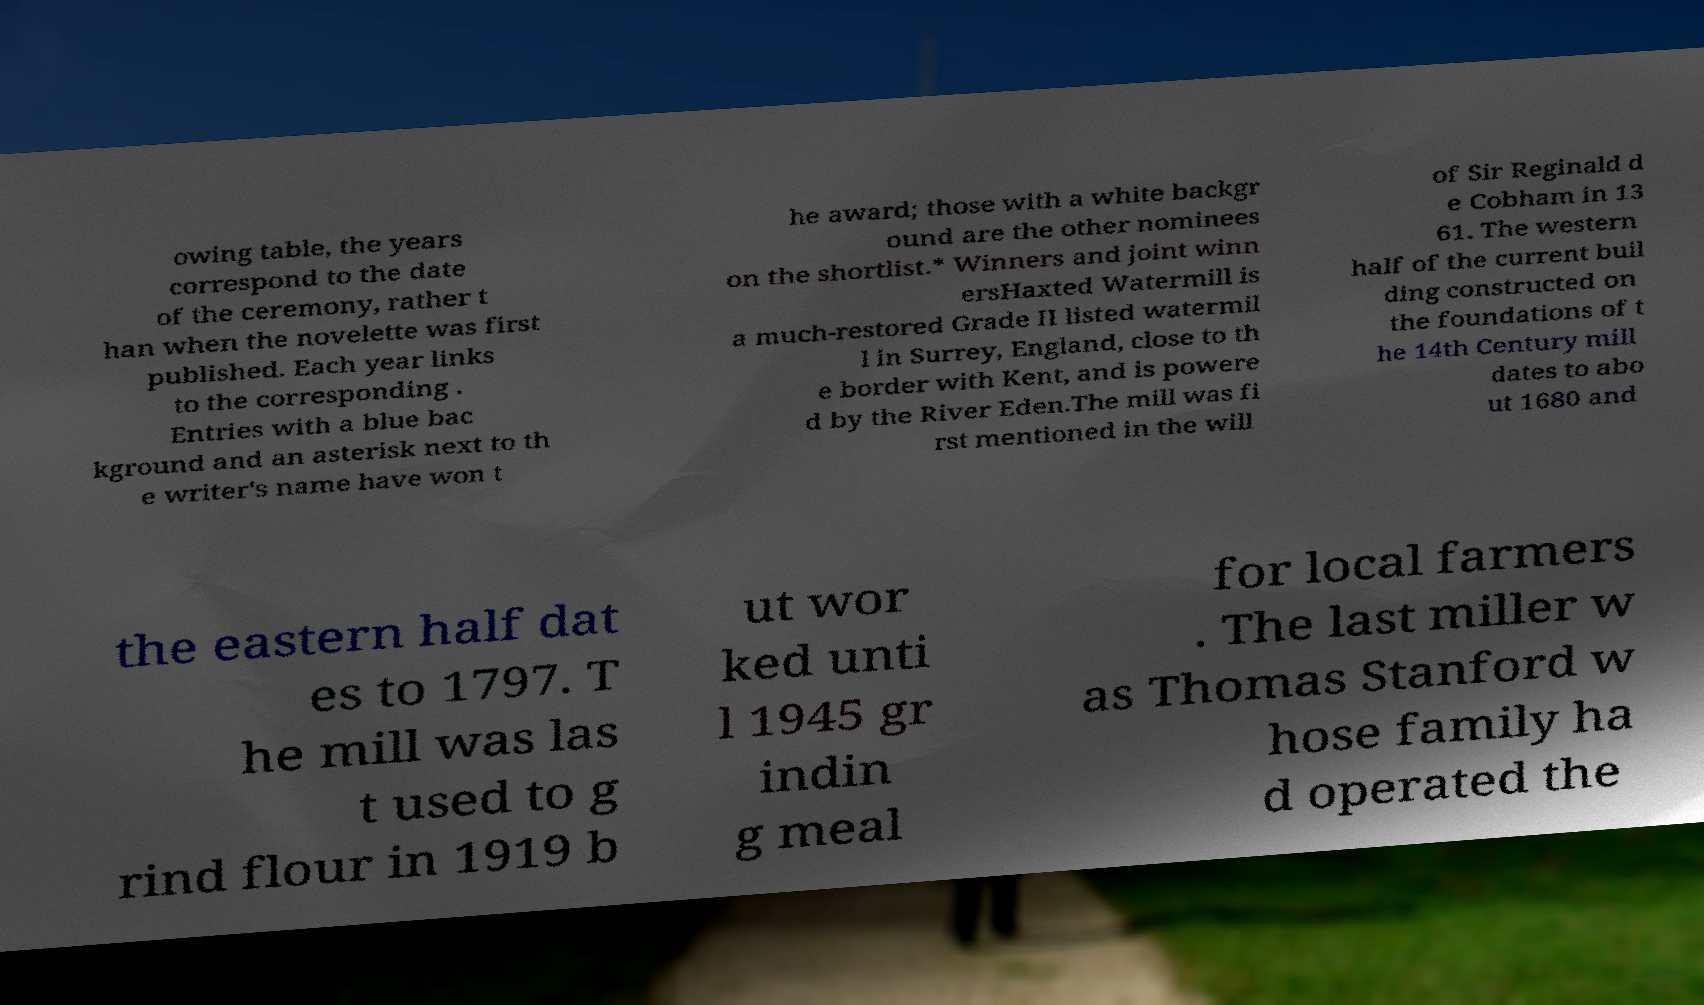Could you assist in decoding the text presented in this image and type it out clearly? owing table, the years correspond to the date of the ceremony, rather t han when the novelette was first published. Each year links to the corresponding . Entries with a blue bac kground and an asterisk next to th e writer's name have won t he award; those with a white backgr ound are the other nominees on the shortlist.* Winners and joint winn ersHaxted Watermill is a much-restored Grade II listed watermil l in Surrey, England, close to th e border with Kent, and is powere d by the River Eden.The mill was fi rst mentioned in the will of Sir Reginald d e Cobham in 13 61. The western half of the current buil ding constructed on the foundations of t he 14th Century mill dates to abo ut 1680 and the eastern half dat es to 1797. T he mill was las t used to g rind flour in 1919 b ut wor ked unti l 1945 gr indin g meal for local farmers . The last miller w as Thomas Stanford w hose family ha d operated the 